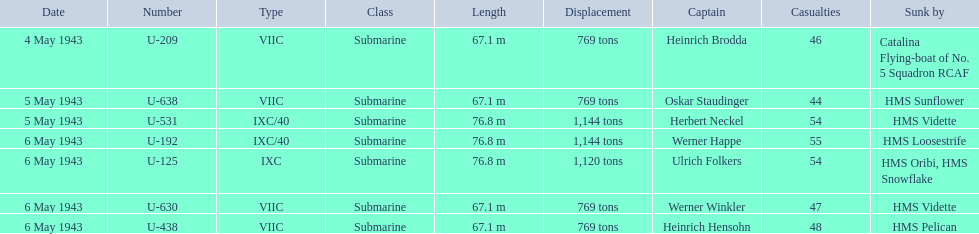Who are all of the captains? Heinrich Brodda, Oskar Staudinger, Herbert Neckel, Werner Happe, Ulrich Folkers, Werner Winkler, Heinrich Hensohn. What sunk each of the captains? Catalina Flying-boat of No. 5 Squadron RCAF, HMS Sunflower, HMS Vidette, HMS Loosestrife, HMS Oribi, HMS Snowflake, HMS Vidette, HMS Pelican. Which was sunk by the hms pelican? Heinrich Hensohn. 